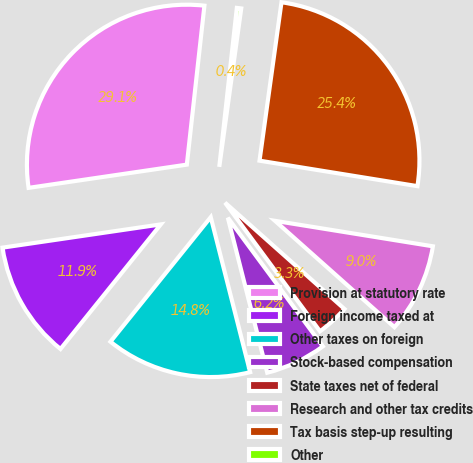Convert chart. <chart><loc_0><loc_0><loc_500><loc_500><pie_chart><fcel>Provision at statutory rate<fcel>Foreign income taxed at<fcel>Other taxes on foreign<fcel>Stock-based compensation<fcel>State taxes net of federal<fcel>Research and other tax credits<fcel>Tax basis step-up resulting<fcel>Other<nl><fcel>29.07%<fcel>11.89%<fcel>14.75%<fcel>6.16%<fcel>3.3%<fcel>9.03%<fcel>25.35%<fcel>0.44%<nl></chart> 